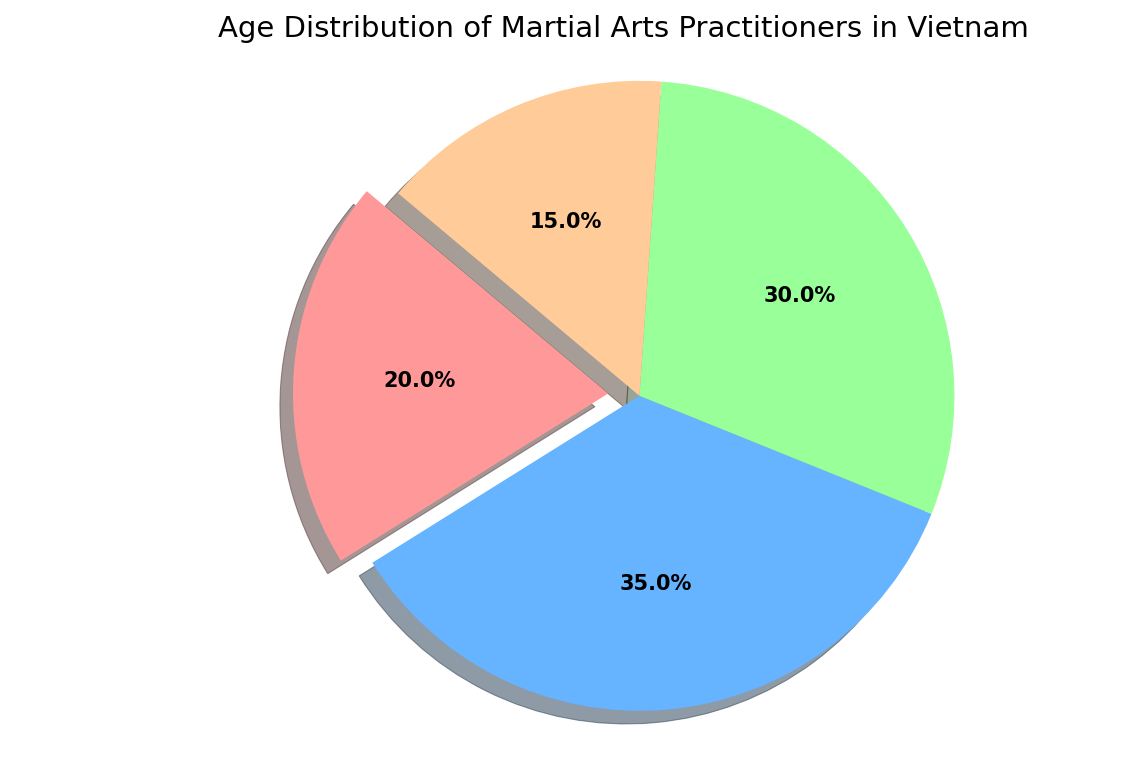What's the largest age group of martial arts practitioners in Vietnam? The pie chart shows the proportion of different age groups. The largest portion belongs to Teenagers (13-19) with 35%.
Answer: Teenagers (13-19) What percentage of martial arts practitioners are younger than 20 years old in Vietnam? Sum the percentages of Children (Under 12) and Teenagers (13-19). Children is 20% and Teenagers is 35%, so 20% + 35% = 55%.
Answer: 55% Which age group has the smallest representation among martial arts practitioners in Vietnam? The pie chart indicates the proportions of each group. The smallest slice belongs to Seniors (Above 40) with 15%.
Answer: Seniors (Above 40) By how much do the percentages of Teenagers (13-19) and Adults (20-40) differ? Teenagers are at 35% and Adults are at 30%. The difference is 35% - 30% = 5%.
Answer: 5% Which age group is represented by the red color in the pie chart? We identify the color sections of the chart. The red section has the label Children (Under 12).
Answer: Children (Under 12) What's the ratio of Adults (20-40) to Seniors (Above 40) among martial arts practitioners in Vietnam? The percentage of Adults (20-40) is 30% and Seniors (Above 40) is 15%. The ratio is 30%/15% = 2/1 or 2:1.
Answer: 2:1 If the total number of practitioners is 1000, how many are Children (Under 12)? Children make up 20% of the practitioners. So, 20% of 1000 is calculated as 0.20 * 1000 = 200.
Answer: 200 Compare the combined percentage of Children and Seniors to the percentage of Adults. Which group is larger and by how much? Combine Children (20%) and Seniors (15%) for a total of 35%. Adults make up 30%. The combined percentage (35%) is larger by 35% - 30% = 5%.
Answer: Combined Children and Seniors by 5% Given the current percentage distribution, if there are 150 practitioners who are Seniors, estimate the total number of practitioners. Seniors represent 15% of the total. If 15% equals 150 practitioners, the total can be calculated as 150 / 0.15 = 1000.
Answer: 1000 